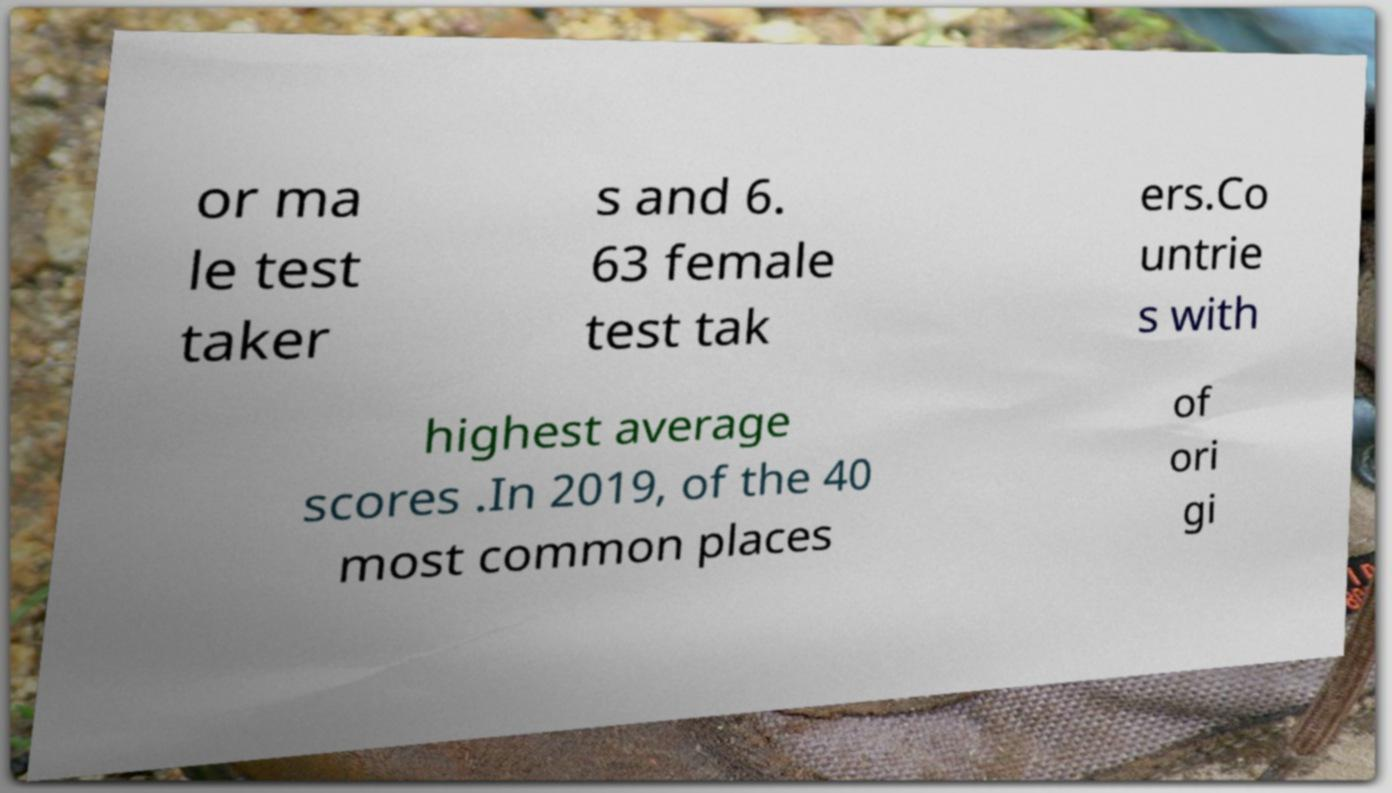For documentation purposes, I need the text within this image transcribed. Could you provide that? or ma le test taker s and 6. 63 female test tak ers.Co untrie s with highest average scores .In 2019, of the 40 most common places of ori gi 